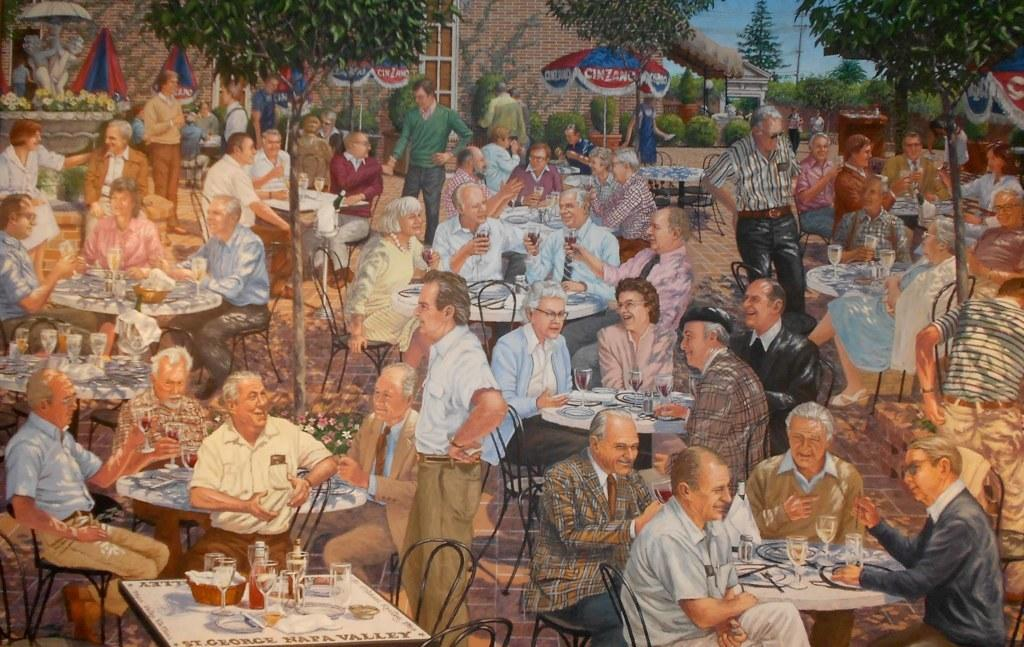What is the main subject of the image? There is a painting in the image. What is happening in the painting? The painting depicts people sitting on chairs. What other objects are present in the image besides the painting? There are tables, glasses, trees, and a building in the image. What type of paper is being used to create the painting in the image? There is no information about the type of paper used to create the painting in the image. What reason might the people sitting on chairs have for being there? The image does not provide any information about the reason for the people sitting on chairs. 